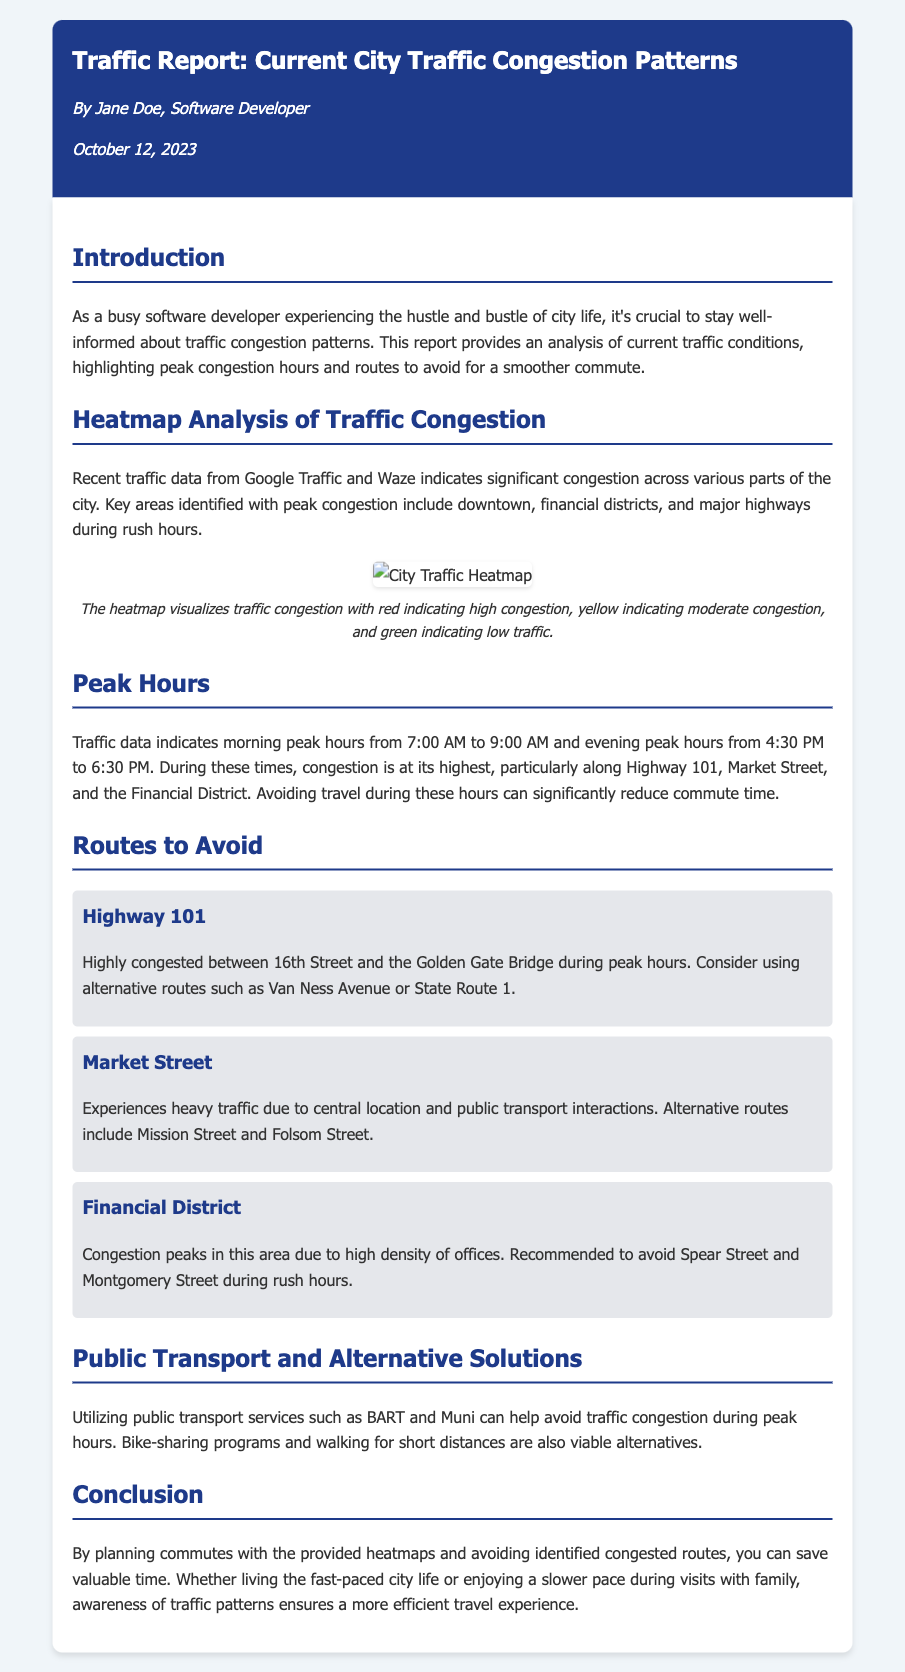what are the morning peak hours? The morning peak hours are specified in the document as the times when traffic is at its highest, which is from 7:00 AM to 9:00 AM.
Answer: 7:00 AM to 9:00 AM which route experiences congestion between 16th Street and the Golden Gate Bridge? This route is mentioned in the report as being highly congested during peak hours, specifically along Highway 101.
Answer: Highway 101 what is the conclusion of the report? The conclusion summarizes the importance of planning commutes based on heatmaps and avoiding congested routes to save time.
Answer: Awareness of traffic patterns what alternative route is recommended for Market Street? The document lists alternative routes for Market Street due to its central location and heavy traffic as Mission Street and Folsom Street.
Answer: Mission Street and Folsom Street when was this traffic report published? The date of publication is mentioned in the document as October 12, 2023.
Answer: October 12, 2023 what public transport services can help avoid traffic congestion? The report suggests using public transport services such as BART and Muni as a way to navigate around traffic during peak hours.
Answer: BART and Muni what color indicates low traffic on the heatmap? The colors used in the heatmap are explained in the document, where green indicates low traffic congestion.
Answer: green what area experiences heavy traffic due to public transport interactions? The document notes Market Street experiences heavy traffic largely because of its interactions with public transportation.
Answer: Market Street 